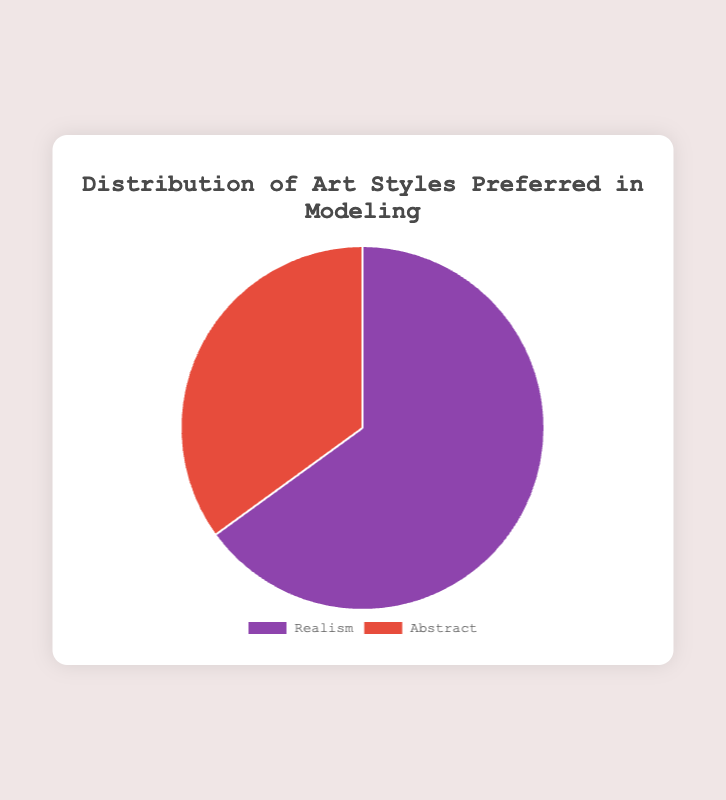What percentage of the participants prefer realism over abstract art style in modeling? The figure shows that 65% prefer realism while 35% prefer abstract. To find the percentage that prefers realism, refer to the portion labeled ‘Realism’ directly.
Answer: 65% What is the total percentage of the participants who prefer either realism or abstract art styles in modeling? Since we are only given two data points, the sum of their percentages must be 100%. Verify by adding the two percentages: 65% (Realism) + 35% (Abstract) = 100%.
Answer: 100% How much larger is the percentage of participants who prefer realism compared to those who prefer abstract? To compare, subtract the smaller percentage (abstract 35%) from the larger percentage (realism 65%). 65% - 35% = 30%.
Answer: 30% Which art style is preferred more in modeling, realism or abstract? By comparing the two segments of the pie chart, the segment for realism is larger. Therefore, realism is preferred more.
Answer: Realism What are the colors used to represent realism and abstract in the pie chart? Visually, the chart uses purple for realism and red for abstract.
Answer: Purple (Realism), Red (Abstract) If you were to visually combine the sections representing each art style, what type of shape would be most evident? Since it's a pie chart with two data points where combined portions make up the whole, the shape would be a full circle if combined.
Answer: A full circle What is the ratio of participants preferring realism to those preferring abstract art? To find the ratio, use the given percentages: realism (65%) and abstract (35%). Convert this to a ratio: 65/35 or simplify to approximately 13:7.
Answer: 13:7 By what factor is the preference for realism greater than the abstract? Divide the percentage of realism (65%) by the percentage of abstract (35%) to find the factor. 65 / 35 = 1.857, which approximates to 1.86.
Answer: 1.86 What portion of the pie chart is occupied by the preference for abstract art? The figure indicates that 35% of the pie chart represents the preference for abstract art.
Answer: 35% If each percent represented one person, how many more people preferred realism over abstract? Calculate the difference in percentages: 65% (realism) - 35% (abstract) = 30%. If each percent equals one person, then 30 more people prefer realism over abstract.
Answer: 30 